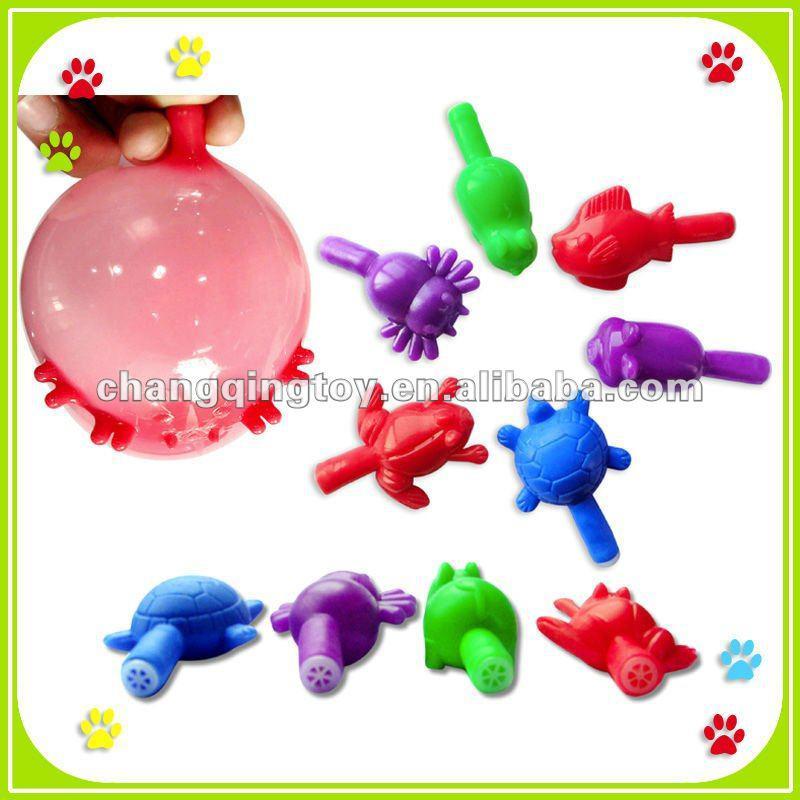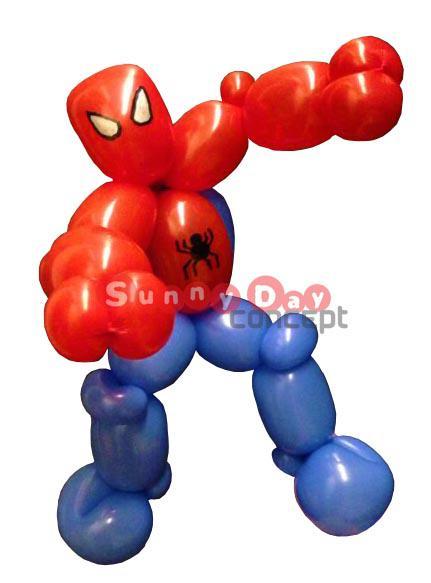The first image is the image on the left, the second image is the image on the right. Examine the images to the left and right. Is the description "One of the balloons is shaped like spiderman." accurate? Answer yes or no. Yes. 